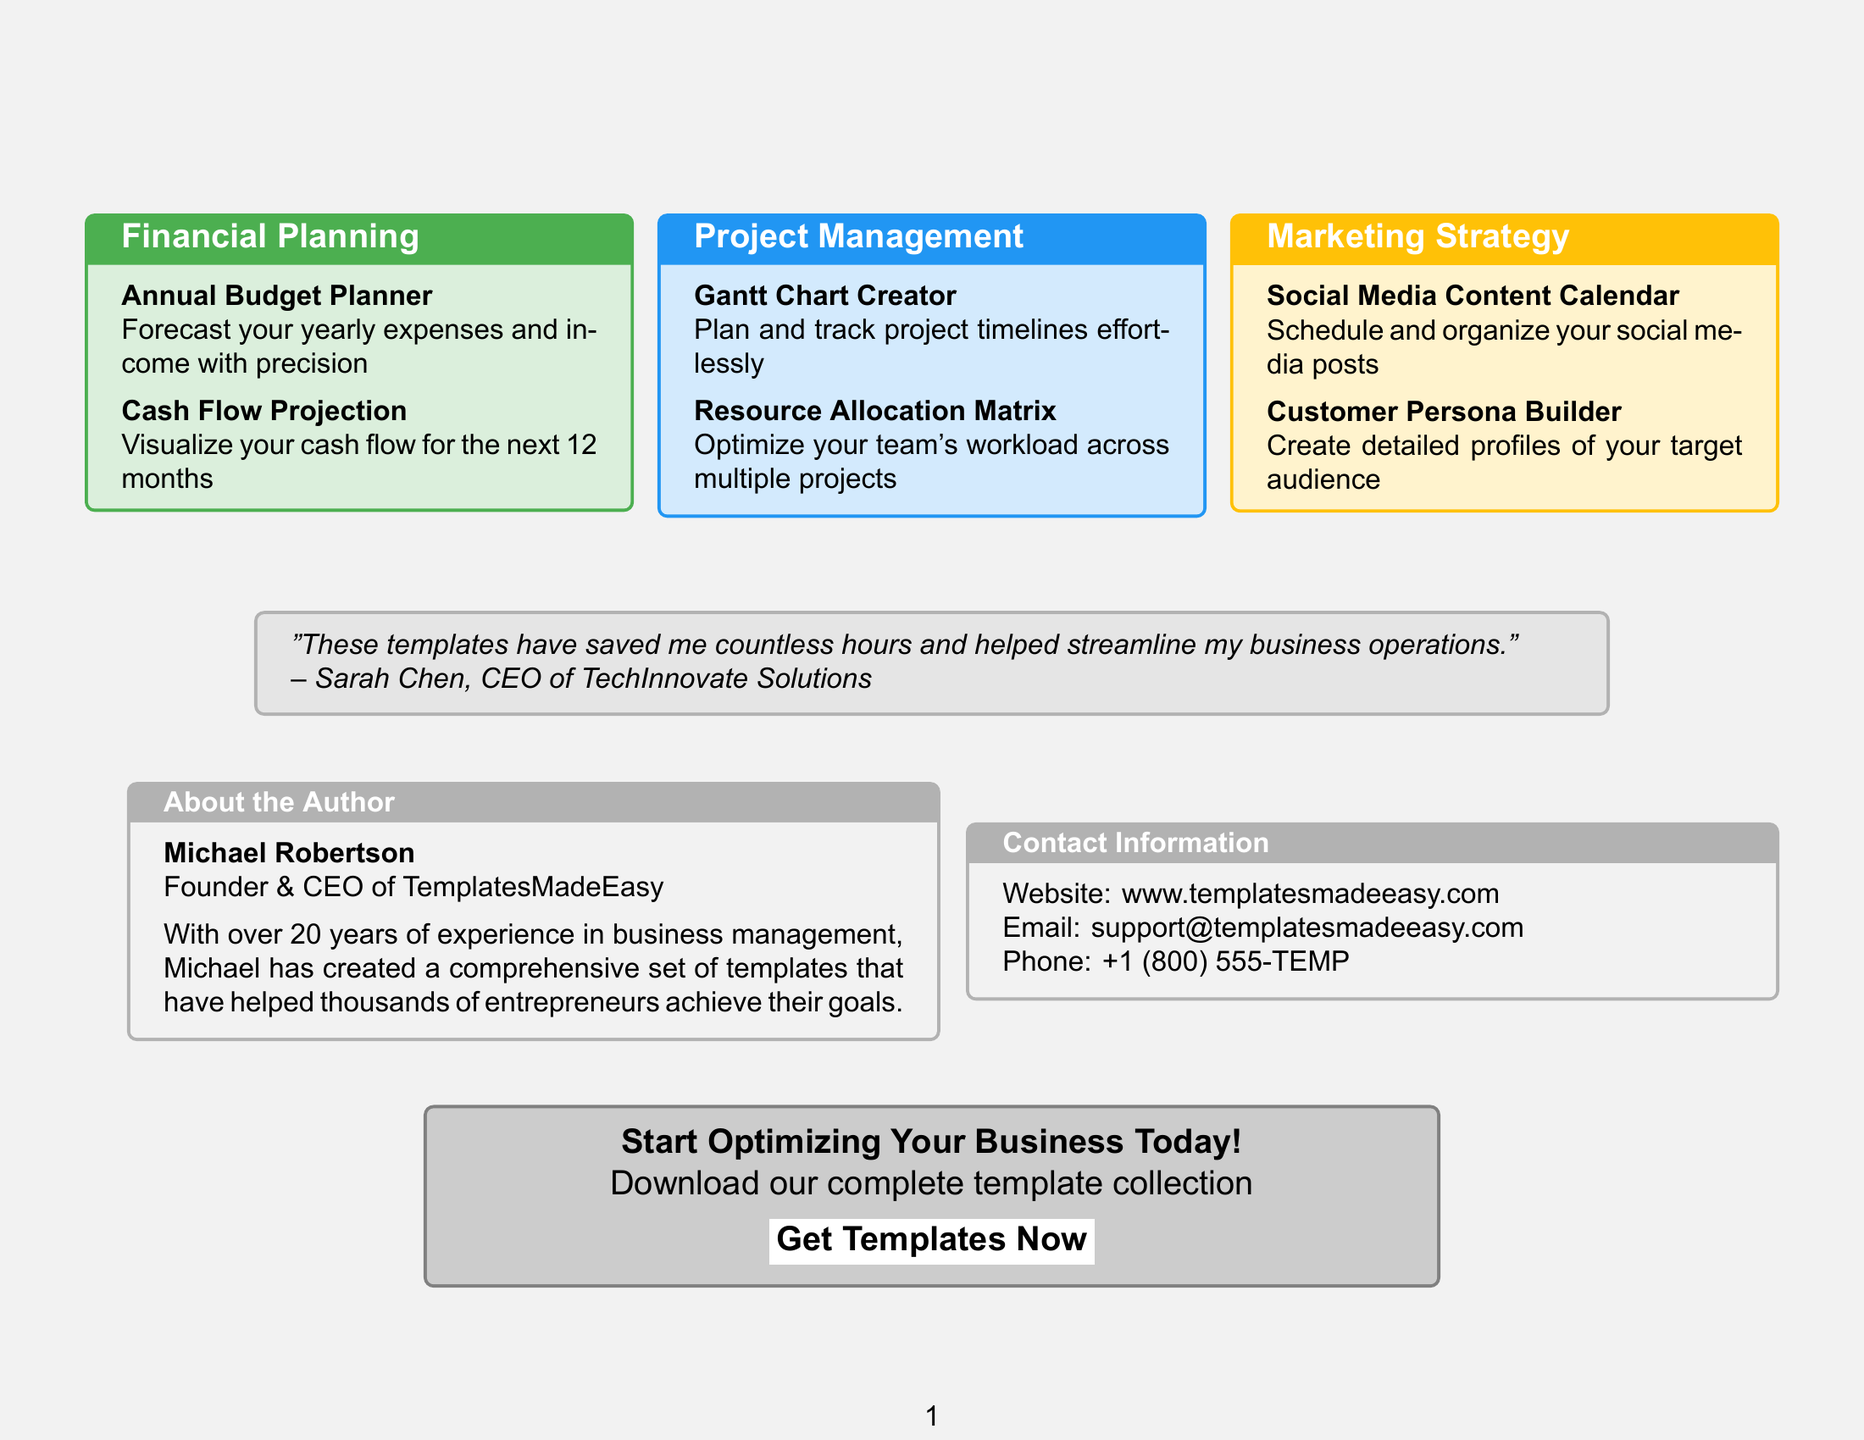What is the brochure title? The brochure title is prominently displayed at the top of the document, indicating its main focus on business templates.
Answer: Business Success Templates: Your Path to Efficiency How many templates are listed under Financial Planning? The document lists two templates specifically under the Financial Planning section.
Answer: 2 Who is the author of the brochure? The author is introduced in the "About the Author" section, providing insight into their background and expertise.
Answer: Michael Robertson What color represents the Project Management section? The Project Management section is color-coded, which helps in visually distinguishing it from other sections.
Answer: #2196F3 What is the main testimonial quote? The quote provides a summary of user satisfaction and is intended to add credibility to the templates offered.
Answer: "These templates have saved me countless hours and helped streamline my business operations." What is the call to action in the brochure? The call to action encourages readers to take immediate steps to benefit from the templates, aimed at driving engagement.
Answer: Start Optimizing Your Business Today! Which template helps with social media posts? This template is specifically designed to assist users in planning and scheduling their social media activities.
Answer: Social Media Content Calendar How long has the author been in business management? This information reflects the author's level of experience, establishing their credibility as a creator of business templates.
Answer: 20 years 